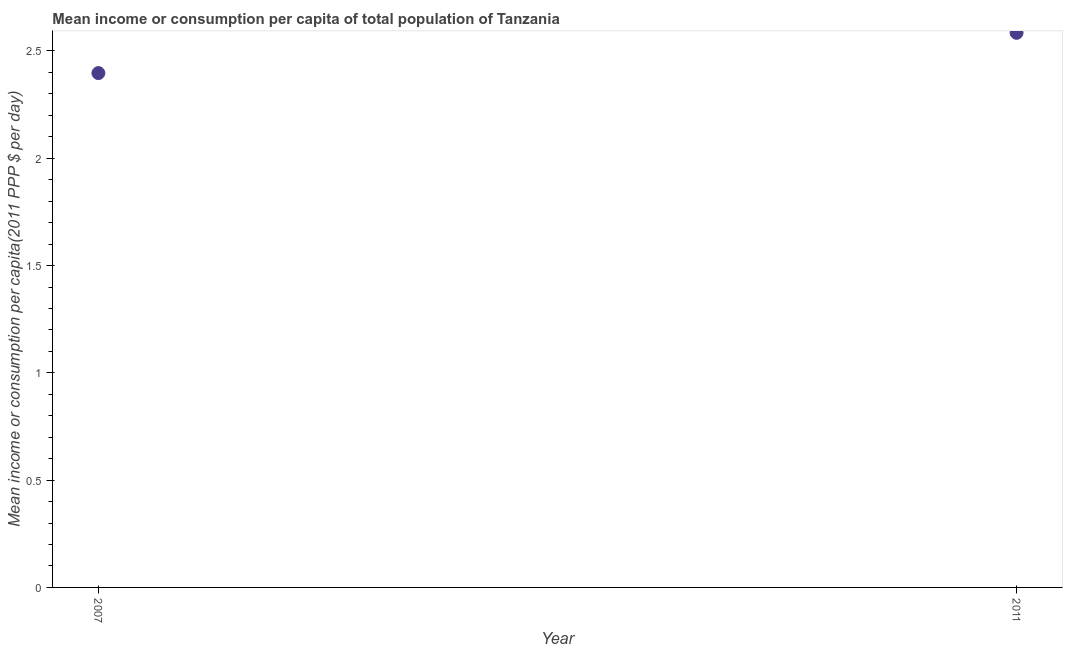What is the mean income or consumption in 2011?
Give a very brief answer. 2.58. Across all years, what is the maximum mean income or consumption?
Provide a succinct answer. 2.58. Across all years, what is the minimum mean income or consumption?
Offer a terse response. 2.4. In which year was the mean income or consumption maximum?
Your answer should be very brief. 2011. What is the sum of the mean income or consumption?
Your answer should be very brief. 4.98. What is the difference between the mean income or consumption in 2007 and 2011?
Offer a very short reply. -0.19. What is the average mean income or consumption per year?
Offer a terse response. 2.49. What is the median mean income or consumption?
Offer a terse response. 2.49. In how many years, is the mean income or consumption greater than 2.1 $?
Provide a short and direct response. 2. What is the ratio of the mean income or consumption in 2007 to that in 2011?
Your response must be concise. 0.93. In how many years, is the mean income or consumption greater than the average mean income or consumption taken over all years?
Your answer should be compact. 1. How many years are there in the graph?
Offer a terse response. 2. What is the difference between two consecutive major ticks on the Y-axis?
Offer a very short reply. 0.5. Are the values on the major ticks of Y-axis written in scientific E-notation?
Ensure brevity in your answer.  No. Does the graph contain grids?
Keep it short and to the point. No. What is the title of the graph?
Your answer should be very brief. Mean income or consumption per capita of total population of Tanzania. What is the label or title of the X-axis?
Make the answer very short. Year. What is the label or title of the Y-axis?
Your response must be concise. Mean income or consumption per capita(2011 PPP $ per day). What is the Mean income or consumption per capita(2011 PPP $ per day) in 2007?
Your answer should be compact. 2.4. What is the Mean income or consumption per capita(2011 PPP $ per day) in 2011?
Your response must be concise. 2.58. What is the difference between the Mean income or consumption per capita(2011 PPP $ per day) in 2007 and 2011?
Offer a very short reply. -0.19. What is the ratio of the Mean income or consumption per capita(2011 PPP $ per day) in 2007 to that in 2011?
Provide a short and direct response. 0.93. 